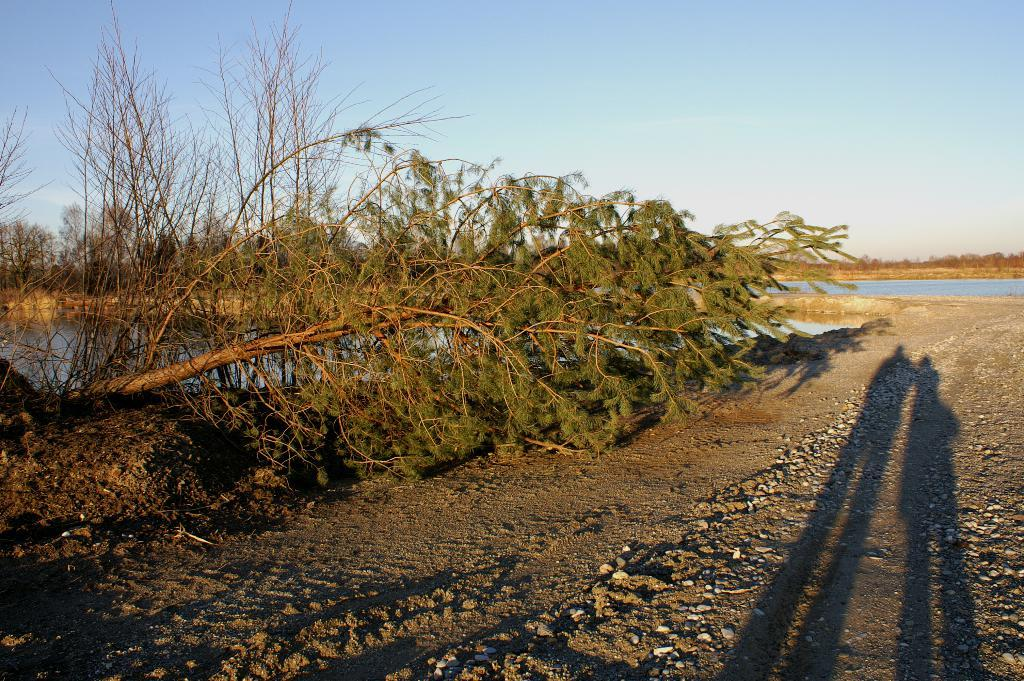What type of vegetation can be seen in the image? There are trees in the image. What natural feature is present in the image besides the trees? There is a water pond in the image. What type of paint is used to create the sound in the image? There is no paint or sound present in the image; it features trees and a water pond. 